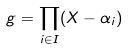<formula> <loc_0><loc_0><loc_500><loc_500>g = \prod _ { i \in I } ( X - \alpha _ { i } )</formula> 